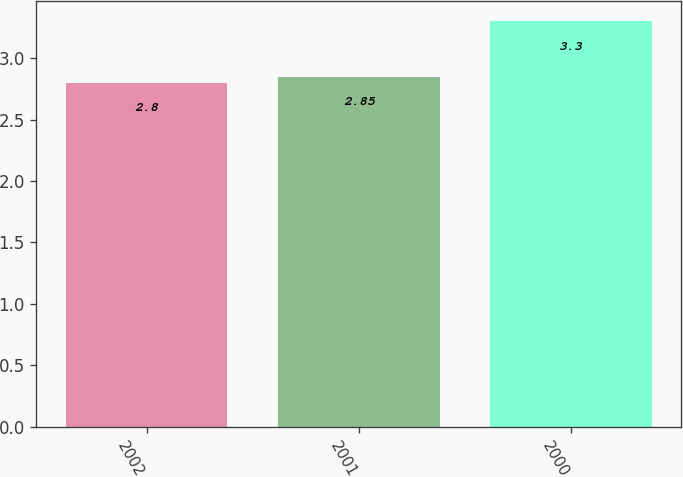<chart> <loc_0><loc_0><loc_500><loc_500><bar_chart><fcel>2002<fcel>2001<fcel>2000<nl><fcel>2.8<fcel>2.85<fcel>3.3<nl></chart> 